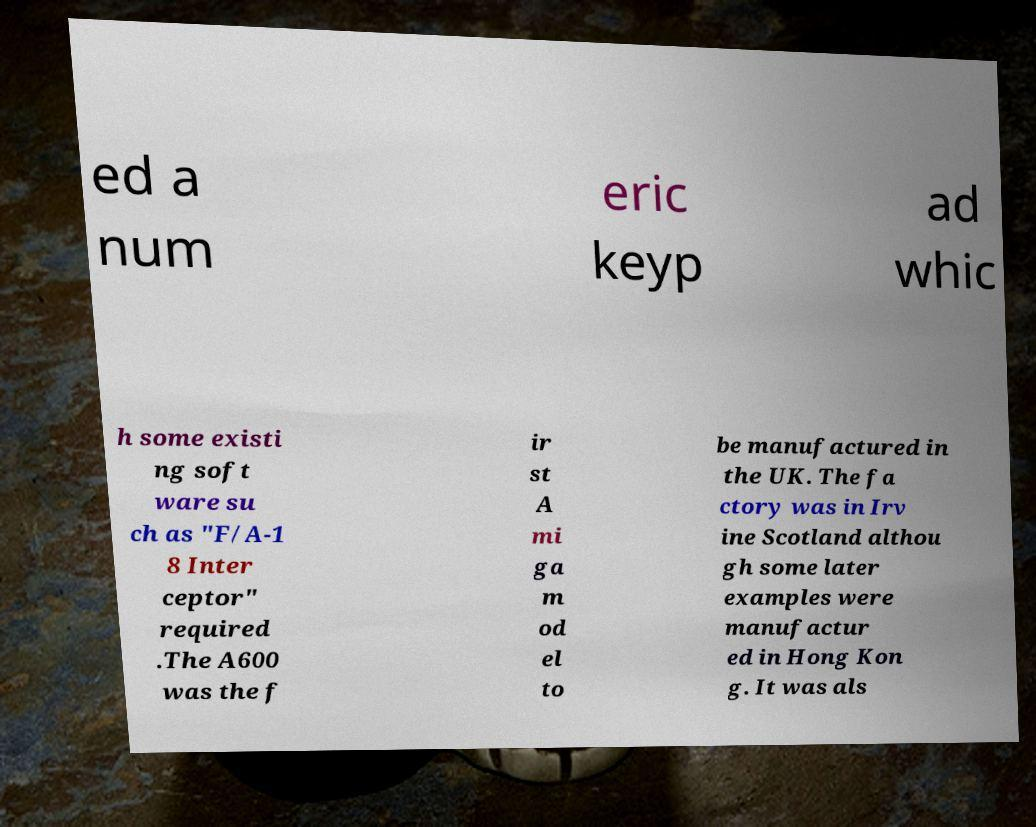For documentation purposes, I need the text within this image transcribed. Could you provide that? ed a num eric keyp ad whic h some existi ng soft ware su ch as "F/A-1 8 Inter ceptor" required .The A600 was the f ir st A mi ga m od el to be manufactured in the UK. The fa ctory was in Irv ine Scotland althou gh some later examples were manufactur ed in Hong Kon g. It was als 